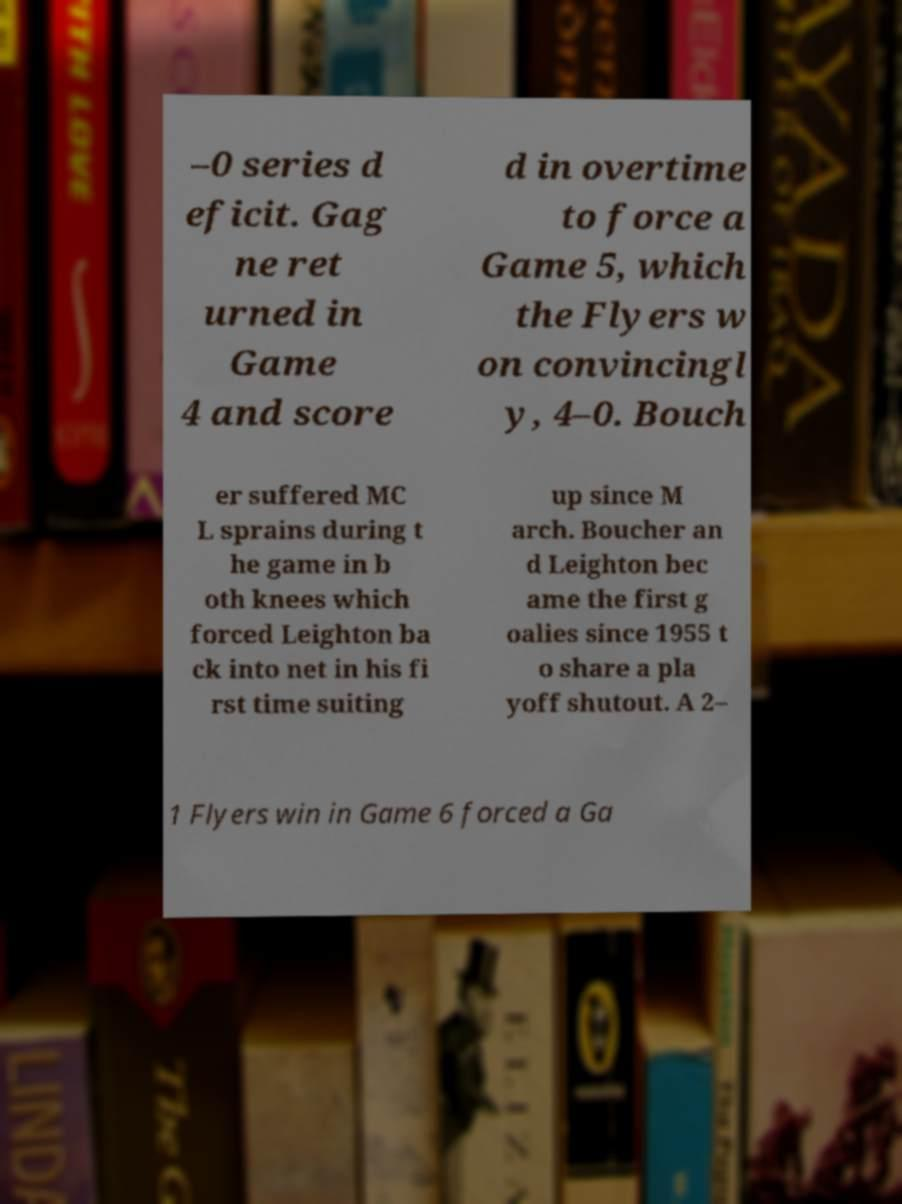For documentation purposes, I need the text within this image transcribed. Could you provide that? –0 series d eficit. Gag ne ret urned in Game 4 and score d in overtime to force a Game 5, which the Flyers w on convincingl y, 4–0. Bouch er suffered MC L sprains during t he game in b oth knees which forced Leighton ba ck into net in his fi rst time suiting up since M arch. Boucher an d Leighton bec ame the first g oalies since 1955 t o share a pla yoff shutout. A 2– 1 Flyers win in Game 6 forced a Ga 